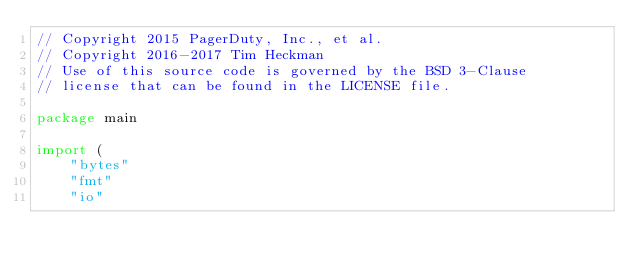Convert code to text. <code><loc_0><loc_0><loc_500><loc_500><_Go_>// Copyright 2015 PagerDuty, Inc., et al.
// Copyright 2016-2017 Tim Heckman
// Use of this source code is governed by the BSD 3-Clause
// license that can be found in the LICENSE file.

package main

import (
	"bytes"
	"fmt"
	"io"</code> 